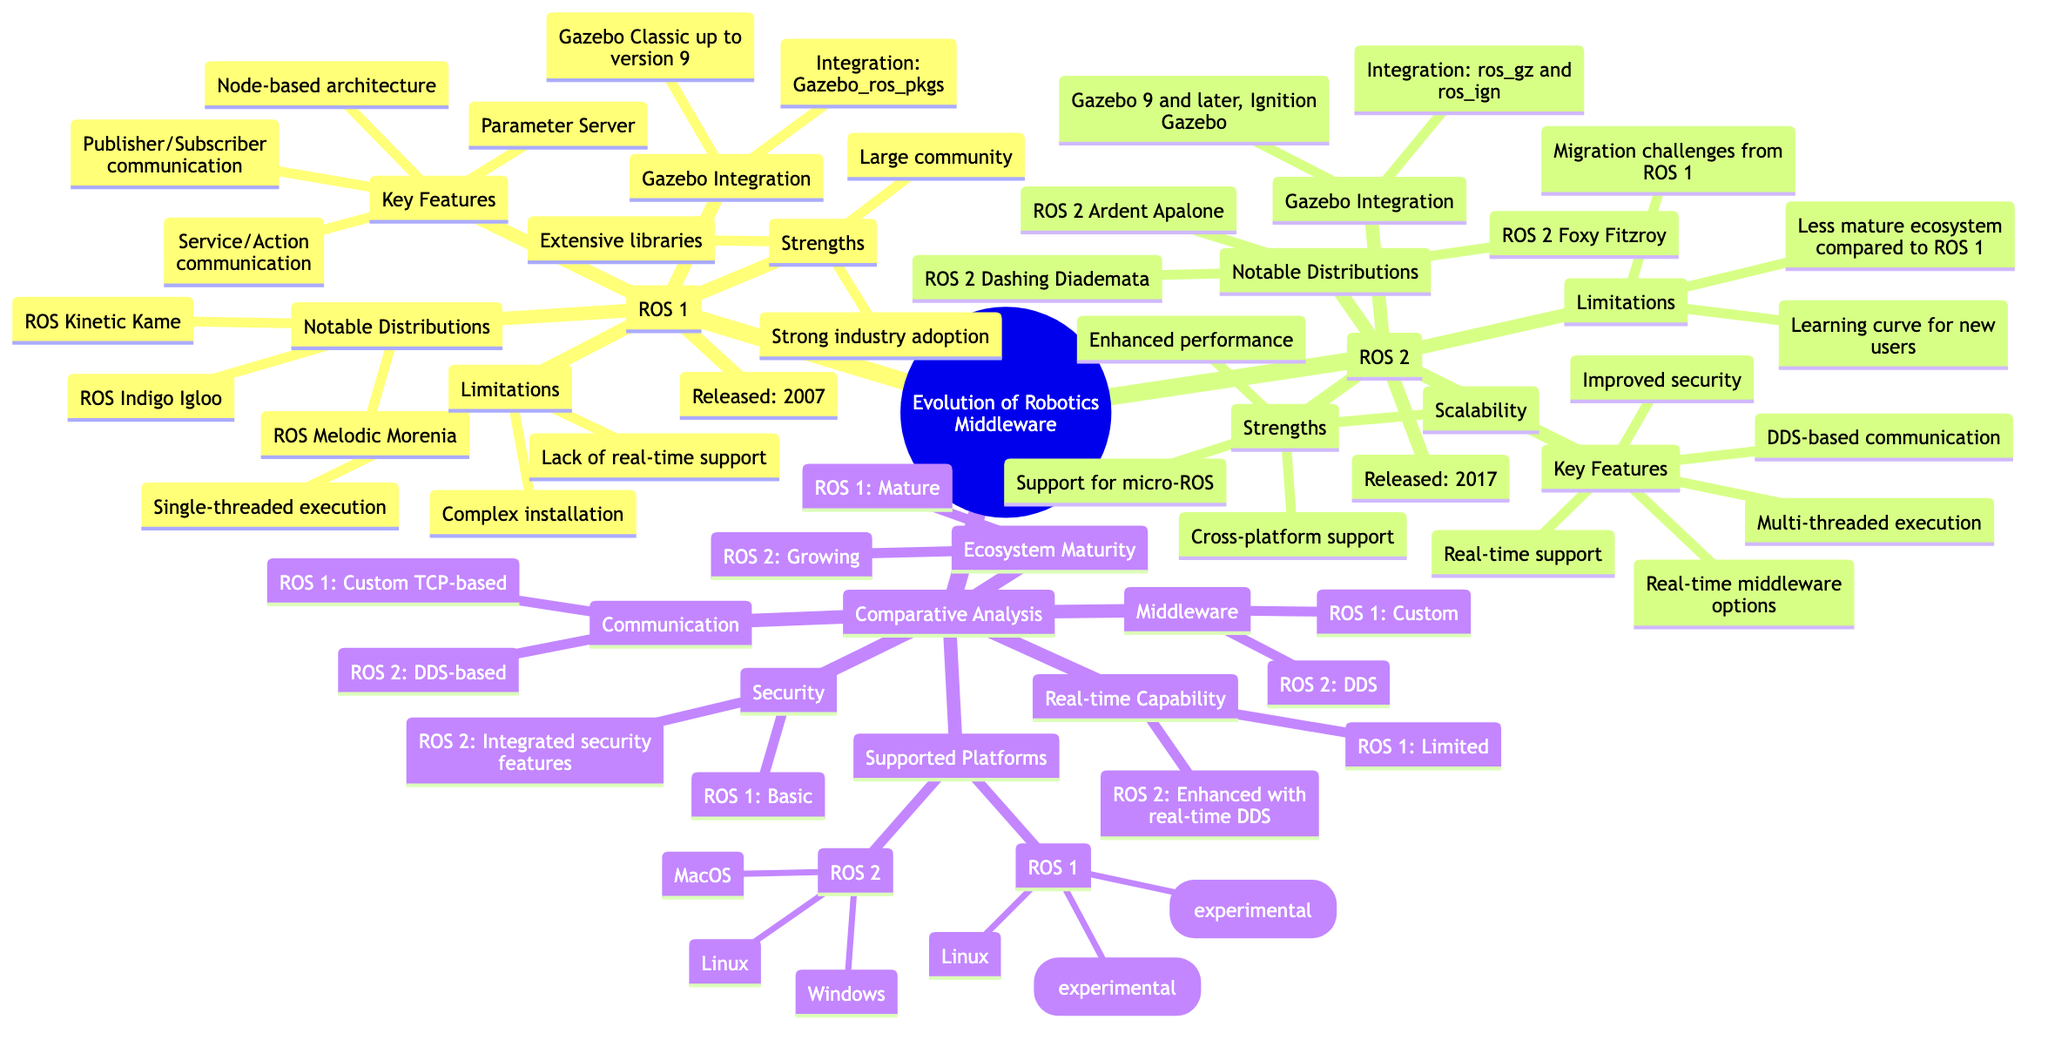What year was ROS 1 released? The diagram specifies "Released: 2007" under the ROS 1 section, directly answering the question of the release year for ROS 1.
Answer: 2007 What are the key features of ROS 2? The diagram lists the key features under the ROS 2 section, including "DDS-based communication," "Real-time support," "Improved security," "Multi-threaded execution," and "Real-time middleware options."
Answer: DDS-based communication, Real-time support, Improved security, Multi-threaded execution, Real-time middleware options What is a notable distribution of ROS 1? The diagram shows notable distributions under the ROS 1 section, specifically highlighting "ROS Indigo Igloo," "ROS Kinetic Kame," and "ROS Melodic Morenia." The question can be answered by mentioning any of these examples.
Answer: ROS Indigo Igloo What is the middleware used in ROS 2? In the "Middleware" comparison section, it is specified that ROS 2 uses "DDS" while ROS 1 uses a "Custom" middleware. Thus, the answer can be found directly in this comparison node.
Answer: DDS How do the community strengths of ROS 1 and ROS 2 compare? ROS 1 cites "Large community" as one of its strengths, while ROS 2 does not mention community in its strengths section but emphasizes attributes like "Scalability" and "Cross-platform support." This implies ROS 1 has a more established community presence.
Answer: Large community Which ROS version has enhanced real-time capabilities? The comparison node for "Real-time Capability" clearly states that ROS 2 has "Enhanced with real-time DDS," whereas ROS 1 is labeled as "Limited." Therefore, the answer indicates which version has improved real-time capabilities.
Answer: ROS 2 How many platforms does ROS 1 support? The diagram lists three platforms under the "Supported Platforms" section for ROS 1: "Linux," "MacOS (experimental)," and "Windows (experimental)," indicating a total of three platforms supported.
Answer: 3 What integration method does ROS 2 use with Gazebo? Under the Gazebo Integration for ROS 2, it states the integration uses "ros_gz and ros_ign." This directly answers the question about the integration method used with Gazebo for ROS 2.
Answer: ros_gz and ros_ign What are some limitations of ROS 2? The diagram in the ROS 2 section lists three limitations: "Learning curve for new users," "Migration challenges from ROS 1," and "Less mature ecosystem compared to ROS 1." Therefore, any of these three can be an answer to the limitations of ROS 2.
Answer: Learning curve for new users 